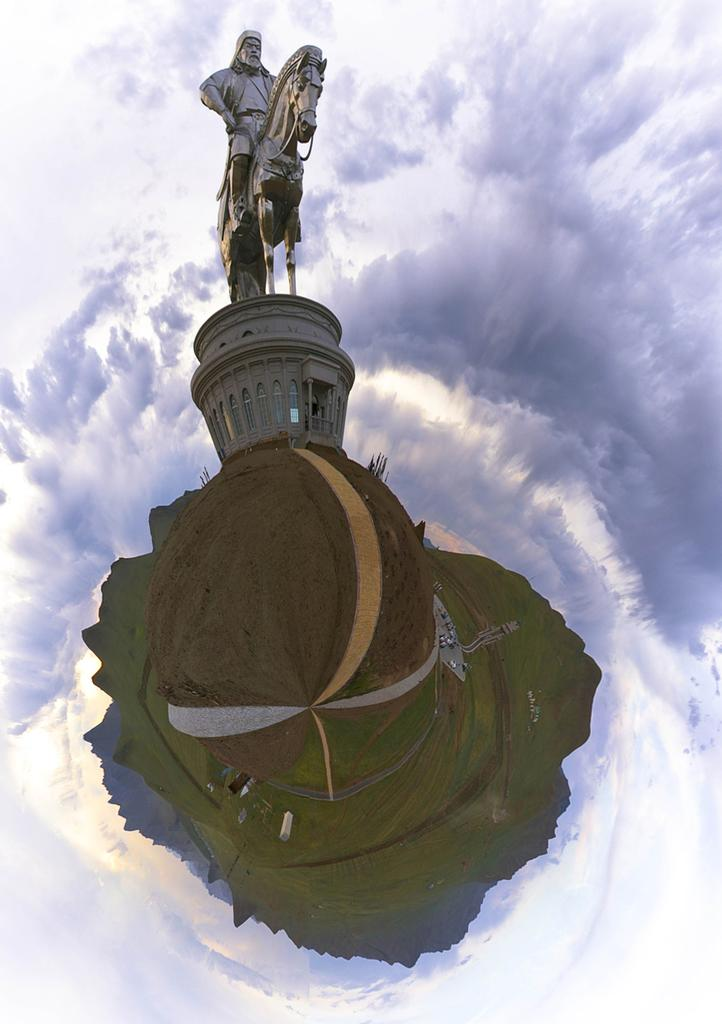What is the main subject in the image? There is a sculpture in the image. What else can be seen in the image besides the sculpture? There is a building and grass visible in the image. Can you describe the white object in the image? There is a white object in the image, but its specific nature is not clear from the provided facts. Can you tell me how many donkeys are present in the image? There is no mention of donkeys in the provided facts, so it cannot be determined if any are present in the image. 